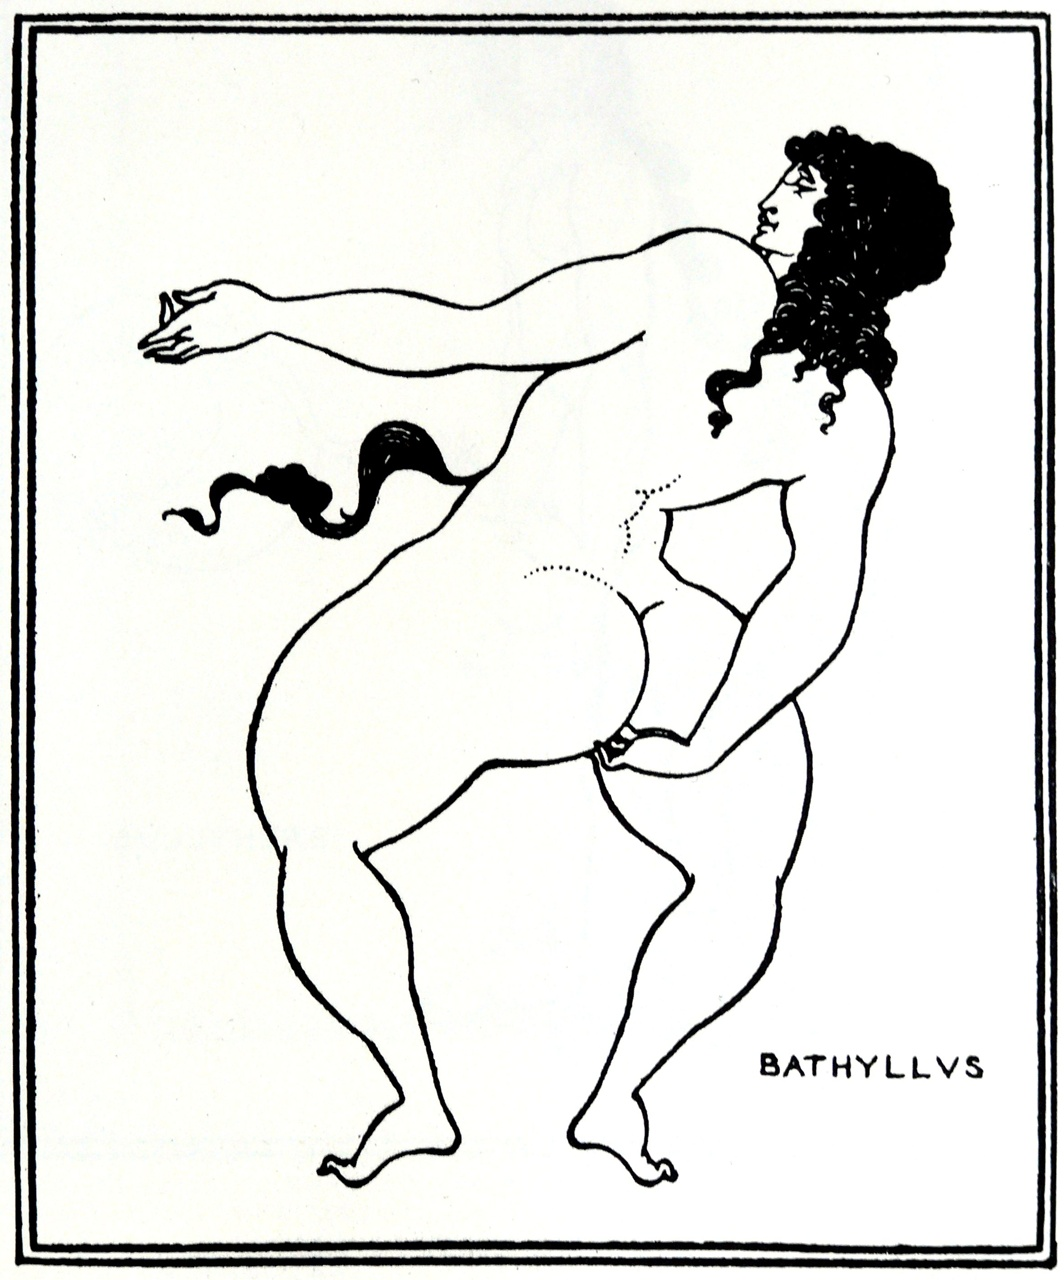Can you elaborate on the elements of the picture provided? The image portrays a stylized black and white line art depicting a nude figure, reminiscent of ancient Greek pottery art. The figure has curly hair and a beard, possibly alluding to a mythological or historical figure. The dynamic pose, with one leg bent at the knee and the other supporting the body, conveys motion and grace. In their right hand, they hold a small, indistinct object, while their left arm extends backward, adding to the sense of movement. The word 'BATHYLLVS' at the bottom possibly refers to the name of the depicted figure or the artist. The minimalistic style and monochromatic palette highlight the elegance and simplicity of line art, inviting viewers to infer a narrative or story behind the figure's stance and expression. 